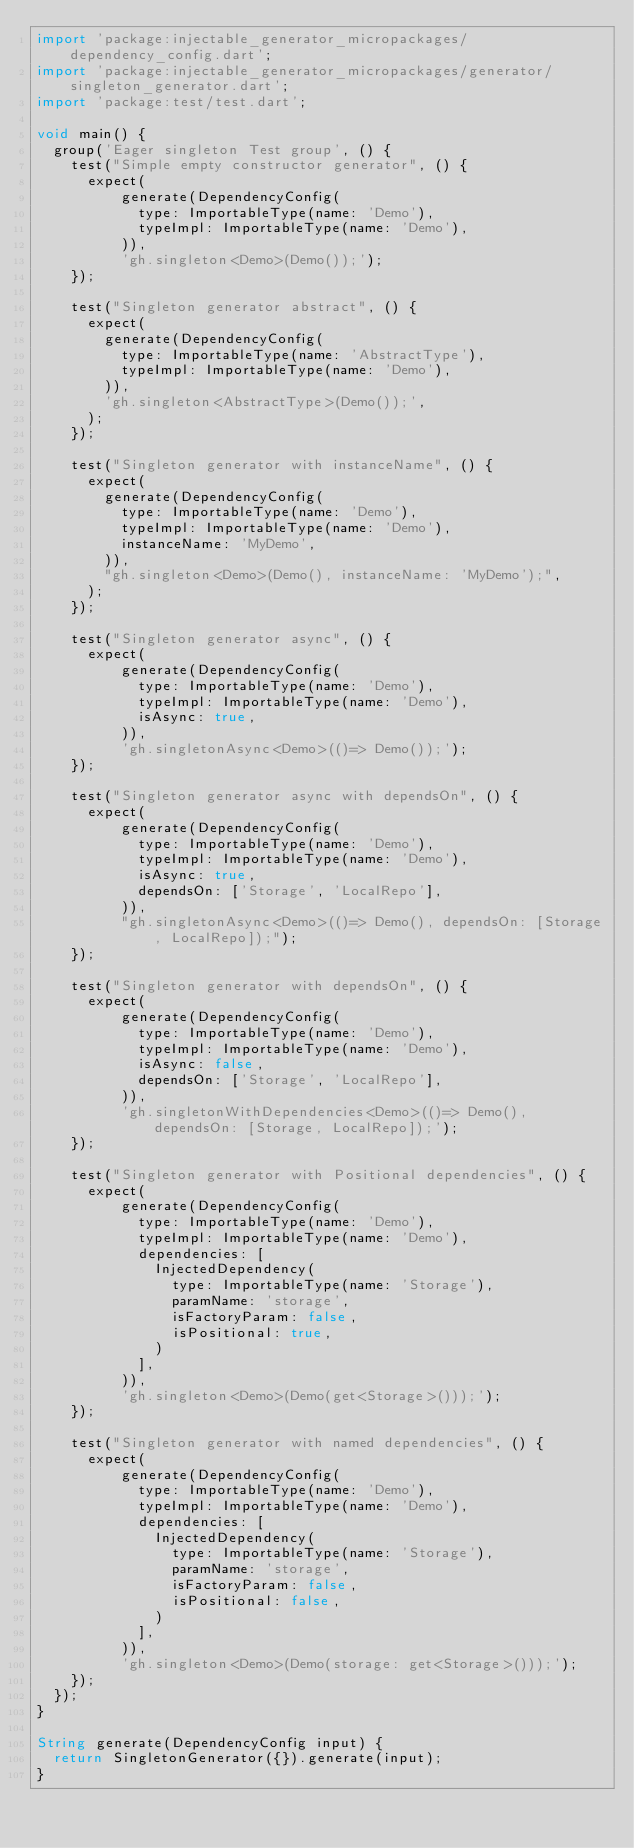<code> <loc_0><loc_0><loc_500><loc_500><_Dart_>import 'package:injectable_generator_micropackages/dependency_config.dart';
import 'package:injectable_generator_micropackages/generator/singleton_generator.dart';
import 'package:test/test.dart';

void main() {
  group('Eager singleton Test group', () {
    test("Simple empty constructor generator", () {
      expect(
          generate(DependencyConfig(
            type: ImportableType(name: 'Demo'),
            typeImpl: ImportableType(name: 'Demo'),
          )),
          'gh.singleton<Demo>(Demo());');
    });

    test("Singleton generator abstract", () {
      expect(
        generate(DependencyConfig(
          type: ImportableType(name: 'AbstractType'),
          typeImpl: ImportableType(name: 'Demo'),
        )),
        'gh.singleton<AbstractType>(Demo());',
      );
    });

    test("Singleton generator with instanceName", () {
      expect(
        generate(DependencyConfig(
          type: ImportableType(name: 'Demo'),
          typeImpl: ImportableType(name: 'Demo'),
          instanceName: 'MyDemo',
        )),
        "gh.singleton<Demo>(Demo(), instanceName: 'MyDemo');",
      );
    });

    test("Singleton generator async", () {
      expect(
          generate(DependencyConfig(
            type: ImportableType(name: 'Demo'),
            typeImpl: ImportableType(name: 'Demo'),
            isAsync: true,
          )),
          'gh.singletonAsync<Demo>(()=> Demo());');
    });

    test("Singleton generator async with dependsOn", () {
      expect(
          generate(DependencyConfig(
            type: ImportableType(name: 'Demo'),
            typeImpl: ImportableType(name: 'Demo'),
            isAsync: true,
            dependsOn: ['Storage', 'LocalRepo'],
          )),
          "gh.singletonAsync<Demo>(()=> Demo(), dependsOn: [Storage, LocalRepo]);");
    });

    test("Singleton generator with dependsOn", () {
      expect(
          generate(DependencyConfig(
            type: ImportableType(name: 'Demo'),
            typeImpl: ImportableType(name: 'Demo'),
            isAsync: false,
            dependsOn: ['Storage', 'LocalRepo'],
          )),
          'gh.singletonWithDependencies<Demo>(()=> Demo(), dependsOn: [Storage, LocalRepo]);');
    });

    test("Singleton generator with Positional dependencies", () {
      expect(
          generate(DependencyConfig(
            type: ImportableType(name: 'Demo'),
            typeImpl: ImportableType(name: 'Demo'),
            dependencies: [
              InjectedDependency(
                type: ImportableType(name: 'Storage'),
                paramName: 'storage',
                isFactoryParam: false,
                isPositional: true,
              )
            ],
          )),
          'gh.singleton<Demo>(Demo(get<Storage>()));');
    });

    test("Singleton generator with named dependencies", () {
      expect(
          generate(DependencyConfig(
            type: ImportableType(name: 'Demo'),
            typeImpl: ImportableType(name: 'Demo'),
            dependencies: [
              InjectedDependency(
                type: ImportableType(name: 'Storage'),
                paramName: 'storage',
                isFactoryParam: false,
                isPositional: false,
              )
            ],
          )),
          'gh.singleton<Demo>(Demo(storage: get<Storage>()));');
    });
  });
}

String generate(DependencyConfig input) {
  return SingletonGenerator({}).generate(input);
}
</code> 